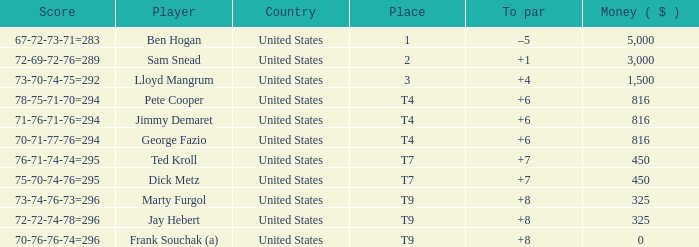How much was paid to the player whose score was 70-71-77-76=294? 816.0. 